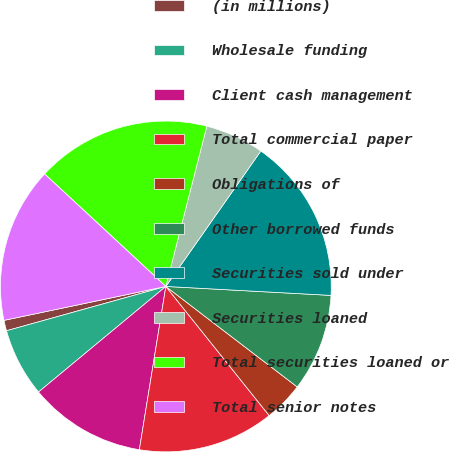Convert chart to OTSL. <chart><loc_0><loc_0><loc_500><loc_500><pie_chart><fcel>(in millions)<fcel>Wholesale funding<fcel>Client cash management<fcel>Total commercial paper<fcel>Obligations of<fcel>Other borrowed funds<fcel>Securities sold under<fcel>Securities loaned<fcel>Total securities loaned or<fcel>Total senior notes<nl><fcel>1.03%<fcel>6.7%<fcel>11.42%<fcel>13.3%<fcel>3.87%<fcel>9.53%<fcel>16.13%<fcel>5.75%<fcel>17.08%<fcel>15.19%<nl></chart> 